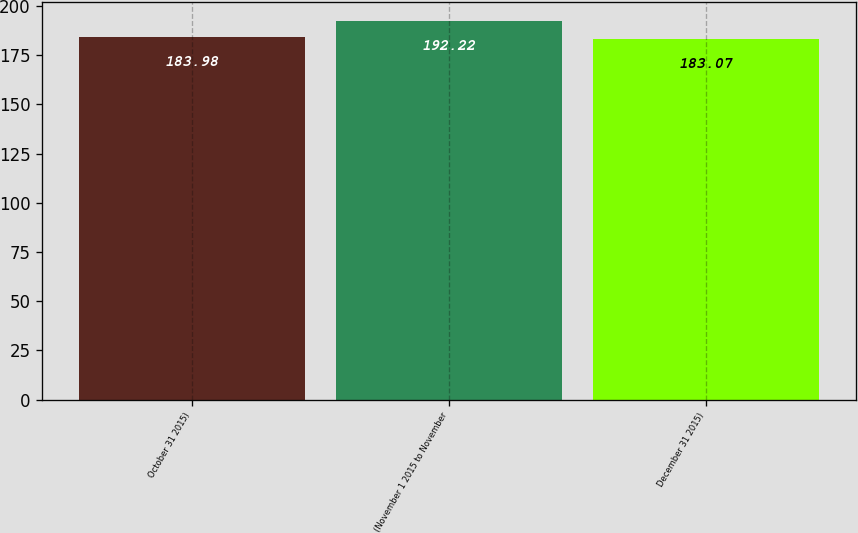<chart> <loc_0><loc_0><loc_500><loc_500><bar_chart><fcel>October 31 2015)<fcel>(November 1 2015 to November<fcel>December 31 2015)<nl><fcel>183.98<fcel>192.22<fcel>183.07<nl></chart> 